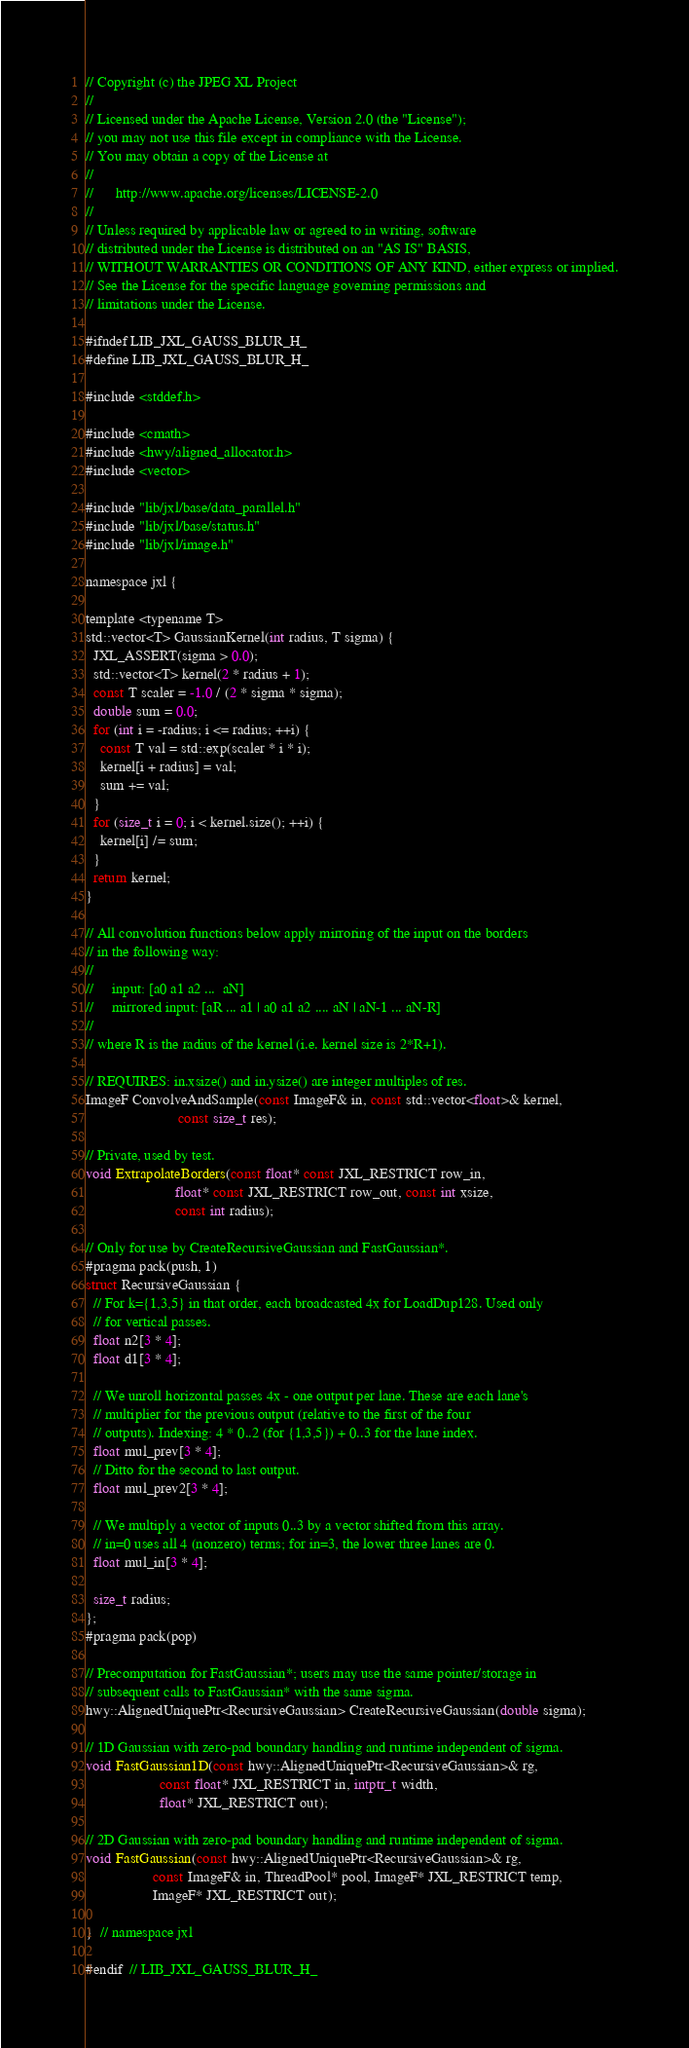<code> <loc_0><loc_0><loc_500><loc_500><_C_>// Copyright (c) the JPEG XL Project
//
// Licensed under the Apache License, Version 2.0 (the "License");
// you may not use this file except in compliance with the License.
// You may obtain a copy of the License at
//
//      http://www.apache.org/licenses/LICENSE-2.0
//
// Unless required by applicable law or agreed to in writing, software
// distributed under the License is distributed on an "AS IS" BASIS,
// WITHOUT WARRANTIES OR CONDITIONS OF ANY KIND, either express or implied.
// See the License for the specific language governing permissions and
// limitations under the License.

#ifndef LIB_JXL_GAUSS_BLUR_H_
#define LIB_JXL_GAUSS_BLUR_H_

#include <stddef.h>

#include <cmath>
#include <hwy/aligned_allocator.h>
#include <vector>

#include "lib/jxl/base/data_parallel.h"
#include "lib/jxl/base/status.h"
#include "lib/jxl/image.h"

namespace jxl {

template <typename T>
std::vector<T> GaussianKernel(int radius, T sigma) {
  JXL_ASSERT(sigma > 0.0);
  std::vector<T> kernel(2 * radius + 1);
  const T scaler = -1.0 / (2 * sigma * sigma);
  double sum = 0.0;
  for (int i = -radius; i <= radius; ++i) {
    const T val = std::exp(scaler * i * i);
    kernel[i + radius] = val;
    sum += val;
  }
  for (size_t i = 0; i < kernel.size(); ++i) {
    kernel[i] /= sum;
  }
  return kernel;
}

// All convolution functions below apply mirroring of the input on the borders
// in the following way:
//
//     input: [a0 a1 a2 ...  aN]
//     mirrored input: [aR ... a1 | a0 a1 a2 .... aN | aN-1 ... aN-R]
//
// where R is the radius of the kernel (i.e. kernel size is 2*R+1).

// REQUIRES: in.xsize() and in.ysize() are integer multiples of res.
ImageF ConvolveAndSample(const ImageF& in, const std::vector<float>& kernel,
                         const size_t res);

// Private, used by test.
void ExtrapolateBorders(const float* const JXL_RESTRICT row_in,
                        float* const JXL_RESTRICT row_out, const int xsize,
                        const int radius);

// Only for use by CreateRecursiveGaussian and FastGaussian*.
#pragma pack(push, 1)
struct RecursiveGaussian {
  // For k={1,3,5} in that order, each broadcasted 4x for LoadDup128. Used only
  // for vertical passes.
  float n2[3 * 4];
  float d1[3 * 4];

  // We unroll horizontal passes 4x - one output per lane. These are each lane's
  // multiplier for the previous output (relative to the first of the four
  // outputs). Indexing: 4 * 0..2 (for {1,3,5}) + 0..3 for the lane index.
  float mul_prev[3 * 4];
  // Ditto for the second to last output.
  float mul_prev2[3 * 4];

  // We multiply a vector of inputs 0..3 by a vector shifted from this array.
  // in=0 uses all 4 (nonzero) terms; for in=3, the lower three lanes are 0.
  float mul_in[3 * 4];

  size_t radius;
};
#pragma pack(pop)

// Precomputation for FastGaussian*; users may use the same pointer/storage in
// subsequent calls to FastGaussian* with the same sigma.
hwy::AlignedUniquePtr<RecursiveGaussian> CreateRecursiveGaussian(double sigma);

// 1D Gaussian with zero-pad boundary handling and runtime independent of sigma.
void FastGaussian1D(const hwy::AlignedUniquePtr<RecursiveGaussian>& rg,
                    const float* JXL_RESTRICT in, intptr_t width,
                    float* JXL_RESTRICT out);

// 2D Gaussian with zero-pad boundary handling and runtime independent of sigma.
void FastGaussian(const hwy::AlignedUniquePtr<RecursiveGaussian>& rg,
                  const ImageF& in, ThreadPool* pool, ImageF* JXL_RESTRICT temp,
                  ImageF* JXL_RESTRICT out);

}  // namespace jxl

#endif  // LIB_JXL_GAUSS_BLUR_H_
</code> 